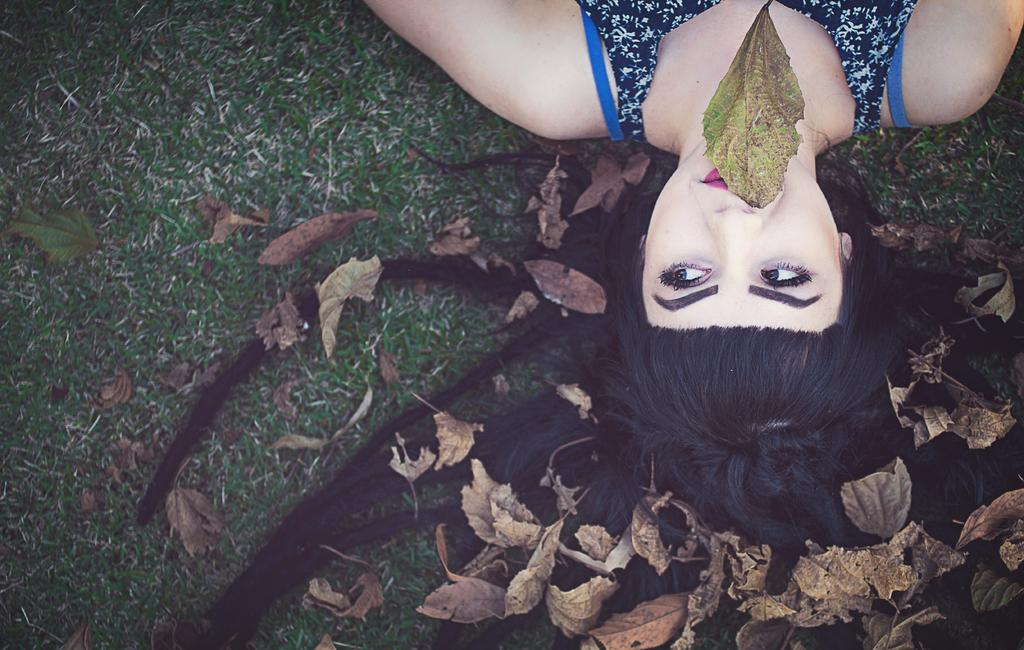What type of natural material can be seen in the image? There are dry leaves in the image. What is the person in the image doing? The person is laying on the grass. What is the person holding in their mouth? The person is holding a dried leaf in their mouth. What type of glass object can be seen in the image? There is no glass object present in the image. What noise can be heard coming from the person in the image? The image is a still picture, so no noise can be heard. 